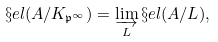Convert formula to latex. <formula><loc_0><loc_0><loc_500><loc_500>\S e l ( A / K _ { \mathfrak { p } ^ { \infty } } ) & = \varinjlim _ { L } \S e l ( A / L ) ,</formula> 